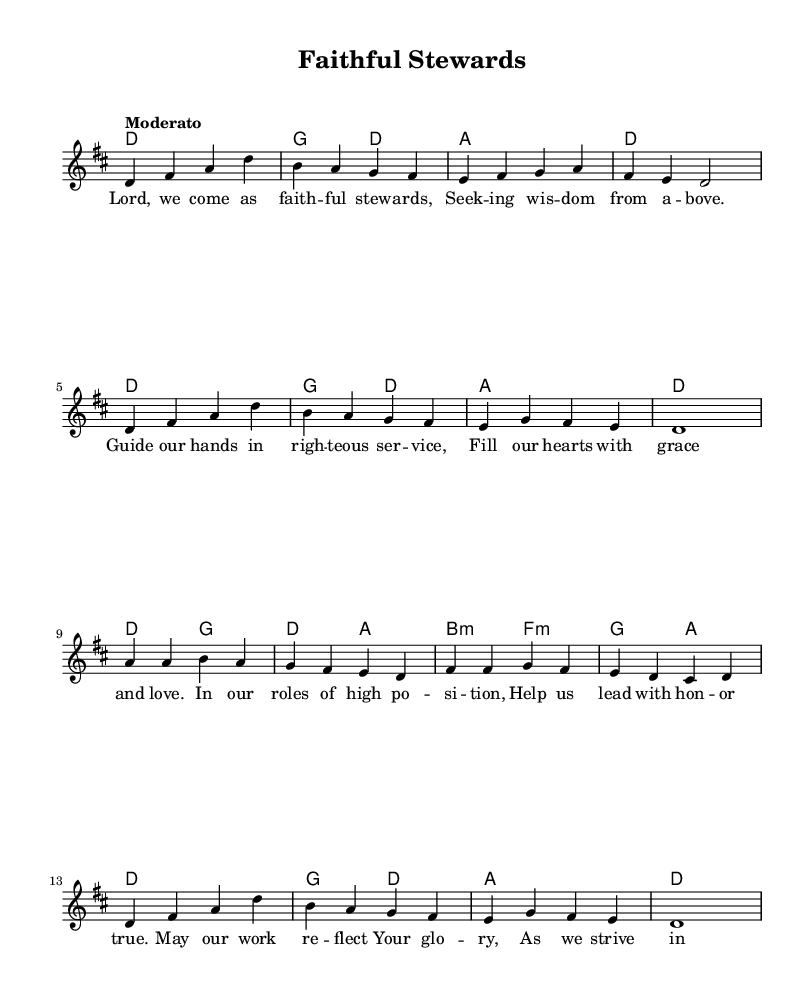What is the key signature of this music? The key signature is D major, which has two sharps (F# and C#).
Answer: D major What is the time signature of this piece? The time signature is 4/4, indicating four beats per measure.
Answer: 4/4 What is the tempo marking indicated in the score? The score indicates a tempo of "Moderato," which suggests a moderate speed.
Answer: Moderato How many measures are in the melody? Counting the notes and rests, there are a total of 8 measures in the melody section.
Answer: 8 What is the first lyric line of this hymn? The first lyric line provided in the sheet music reads, "Lord, we come as faithful stewards."
Answer: Lord, we come as faithful stewards Which chord is played on the first measure? The chord played on the first measure is D major, which corresponds to the tonic of the key.
Answer: D major How many times does the phrase "as we strive in all we do" appear in the lyrics? The phrase appears once in the lyrics, specifically at the end of the second stanza.
Answer: Once 